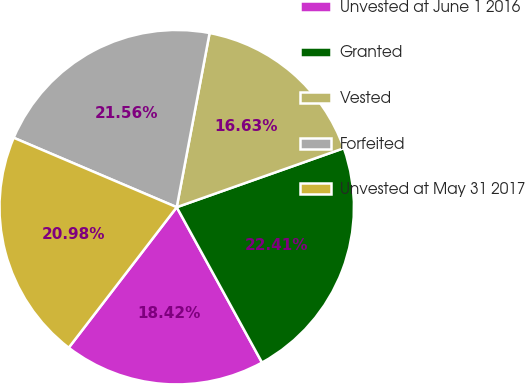Convert chart to OTSL. <chart><loc_0><loc_0><loc_500><loc_500><pie_chart><fcel>Unvested at June 1 2016<fcel>Granted<fcel>Vested<fcel>Forfeited<fcel>Unvested at May 31 2017<nl><fcel>18.42%<fcel>22.41%<fcel>16.63%<fcel>21.56%<fcel>20.98%<nl></chart> 